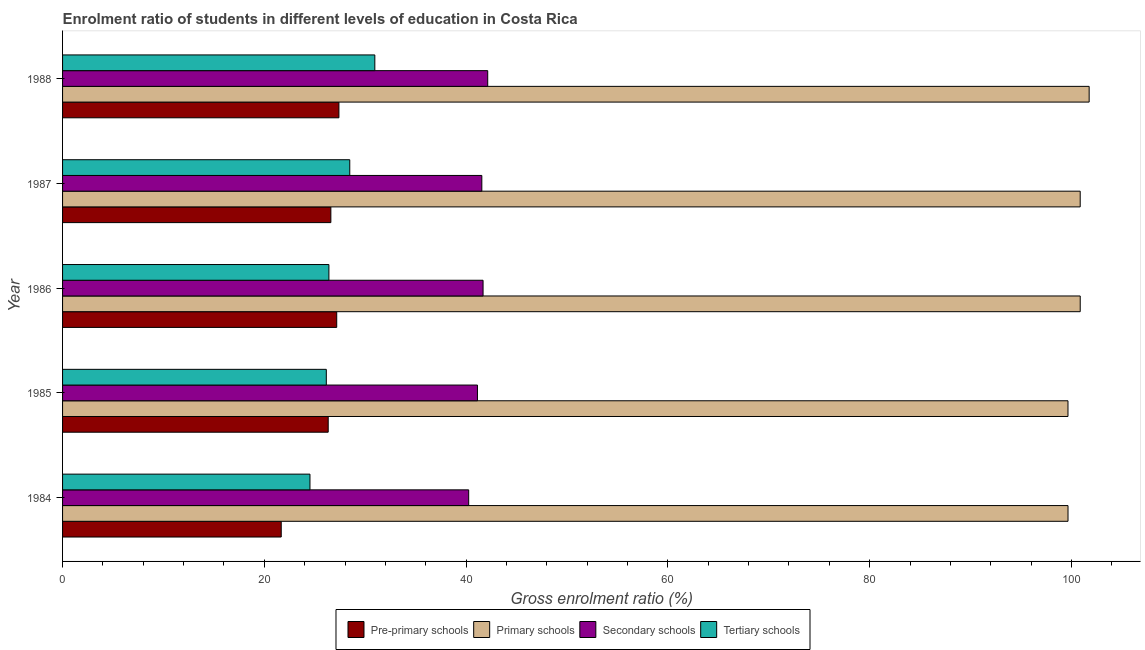How many groups of bars are there?
Provide a short and direct response. 5. Are the number of bars per tick equal to the number of legend labels?
Make the answer very short. Yes. What is the label of the 4th group of bars from the top?
Give a very brief answer. 1985. What is the gross enrolment ratio in primary schools in 1984?
Keep it short and to the point. 99.66. Across all years, what is the maximum gross enrolment ratio in tertiary schools?
Make the answer very short. 30.95. Across all years, what is the minimum gross enrolment ratio in tertiary schools?
Keep it short and to the point. 24.52. What is the total gross enrolment ratio in pre-primary schools in the graph?
Provide a short and direct response. 129.17. What is the difference between the gross enrolment ratio in tertiary schools in 1985 and that in 1986?
Provide a short and direct response. -0.26. What is the difference between the gross enrolment ratio in secondary schools in 1988 and the gross enrolment ratio in pre-primary schools in 1986?
Make the answer very short. 14.97. What is the average gross enrolment ratio in tertiary schools per year?
Your answer should be compact. 27.3. In the year 1985, what is the difference between the gross enrolment ratio in tertiary schools and gross enrolment ratio in primary schools?
Your response must be concise. -73.52. In how many years, is the gross enrolment ratio in primary schools greater than 48 %?
Give a very brief answer. 5. What is the ratio of the gross enrolment ratio in pre-primary schools in 1985 to that in 1988?
Keep it short and to the point. 0.96. What is the difference between the highest and the second highest gross enrolment ratio in pre-primary schools?
Make the answer very short. 0.22. What is the difference between the highest and the lowest gross enrolment ratio in tertiary schools?
Your answer should be very brief. 6.43. In how many years, is the gross enrolment ratio in primary schools greater than the average gross enrolment ratio in primary schools taken over all years?
Offer a very short reply. 3. Is the sum of the gross enrolment ratio in tertiary schools in 1985 and 1987 greater than the maximum gross enrolment ratio in primary schools across all years?
Ensure brevity in your answer.  No. What does the 1st bar from the top in 1987 represents?
Keep it short and to the point. Tertiary schools. What does the 4th bar from the bottom in 1988 represents?
Offer a terse response. Tertiary schools. Is it the case that in every year, the sum of the gross enrolment ratio in pre-primary schools and gross enrolment ratio in primary schools is greater than the gross enrolment ratio in secondary schools?
Give a very brief answer. Yes. Are all the bars in the graph horizontal?
Offer a terse response. Yes. Are the values on the major ticks of X-axis written in scientific E-notation?
Give a very brief answer. No. Does the graph contain any zero values?
Offer a terse response. No. Where does the legend appear in the graph?
Your response must be concise. Bottom center. How many legend labels are there?
Give a very brief answer. 4. How are the legend labels stacked?
Your answer should be very brief. Horizontal. What is the title of the graph?
Your response must be concise. Enrolment ratio of students in different levels of education in Costa Rica. What is the label or title of the X-axis?
Provide a short and direct response. Gross enrolment ratio (%). What is the Gross enrolment ratio (%) in Pre-primary schools in 1984?
Offer a terse response. 21.67. What is the Gross enrolment ratio (%) in Primary schools in 1984?
Ensure brevity in your answer.  99.66. What is the Gross enrolment ratio (%) in Secondary schools in 1984?
Provide a short and direct response. 40.26. What is the Gross enrolment ratio (%) of Tertiary schools in 1984?
Offer a very short reply. 24.52. What is the Gross enrolment ratio (%) in Pre-primary schools in 1985?
Ensure brevity in your answer.  26.33. What is the Gross enrolment ratio (%) of Primary schools in 1985?
Your response must be concise. 99.66. What is the Gross enrolment ratio (%) of Secondary schools in 1985?
Give a very brief answer. 41.13. What is the Gross enrolment ratio (%) of Tertiary schools in 1985?
Your answer should be very brief. 26.14. What is the Gross enrolment ratio (%) of Pre-primary schools in 1986?
Give a very brief answer. 27.17. What is the Gross enrolment ratio (%) of Primary schools in 1986?
Your answer should be compact. 100.87. What is the Gross enrolment ratio (%) of Secondary schools in 1986?
Ensure brevity in your answer.  41.68. What is the Gross enrolment ratio (%) in Tertiary schools in 1986?
Your answer should be very brief. 26.4. What is the Gross enrolment ratio (%) of Pre-primary schools in 1987?
Provide a succinct answer. 26.59. What is the Gross enrolment ratio (%) of Primary schools in 1987?
Give a very brief answer. 100.87. What is the Gross enrolment ratio (%) of Secondary schools in 1987?
Your response must be concise. 41.56. What is the Gross enrolment ratio (%) of Tertiary schools in 1987?
Offer a very short reply. 28.47. What is the Gross enrolment ratio (%) in Pre-primary schools in 1988?
Provide a short and direct response. 27.39. What is the Gross enrolment ratio (%) of Primary schools in 1988?
Ensure brevity in your answer.  101.76. What is the Gross enrolment ratio (%) in Secondary schools in 1988?
Offer a terse response. 42.14. What is the Gross enrolment ratio (%) in Tertiary schools in 1988?
Offer a terse response. 30.95. Across all years, what is the maximum Gross enrolment ratio (%) in Pre-primary schools?
Provide a short and direct response. 27.39. Across all years, what is the maximum Gross enrolment ratio (%) in Primary schools?
Give a very brief answer. 101.76. Across all years, what is the maximum Gross enrolment ratio (%) of Secondary schools?
Give a very brief answer. 42.14. Across all years, what is the maximum Gross enrolment ratio (%) in Tertiary schools?
Offer a terse response. 30.95. Across all years, what is the minimum Gross enrolment ratio (%) of Pre-primary schools?
Your answer should be compact. 21.67. Across all years, what is the minimum Gross enrolment ratio (%) in Primary schools?
Your answer should be compact. 99.66. Across all years, what is the minimum Gross enrolment ratio (%) in Secondary schools?
Your response must be concise. 40.26. Across all years, what is the minimum Gross enrolment ratio (%) in Tertiary schools?
Your response must be concise. 24.52. What is the total Gross enrolment ratio (%) in Pre-primary schools in the graph?
Provide a succinct answer. 129.17. What is the total Gross enrolment ratio (%) of Primary schools in the graph?
Your response must be concise. 502.82. What is the total Gross enrolment ratio (%) in Secondary schools in the graph?
Your answer should be very brief. 206.76. What is the total Gross enrolment ratio (%) of Tertiary schools in the graph?
Make the answer very short. 136.48. What is the difference between the Gross enrolment ratio (%) in Pre-primary schools in 1984 and that in 1985?
Your answer should be very brief. -4.66. What is the difference between the Gross enrolment ratio (%) of Primary schools in 1984 and that in 1985?
Keep it short and to the point. 0. What is the difference between the Gross enrolment ratio (%) of Secondary schools in 1984 and that in 1985?
Offer a terse response. -0.87. What is the difference between the Gross enrolment ratio (%) of Tertiary schools in 1984 and that in 1985?
Your answer should be very brief. -1.62. What is the difference between the Gross enrolment ratio (%) of Pre-primary schools in 1984 and that in 1986?
Provide a succinct answer. -5.5. What is the difference between the Gross enrolment ratio (%) of Primary schools in 1984 and that in 1986?
Offer a very short reply. -1.21. What is the difference between the Gross enrolment ratio (%) of Secondary schools in 1984 and that in 1986?
Your answer should be compact. -1.43. What is the difference between the Gross enrolment ratio (%) of Tertiary schools in 1984 and that in 1986?
Give a very brief answer. -1.88. What is the difference between the Gross enrolment ratio (%) in Pre-primary schools in 1984 and that in 1987?
Offer a terse response. -4.92. What is the difference between the Gross enrolment ratio (%) in Primary schools in 1984 and that in 1987?
Offer a terse response. -1.21. What is the difference between the Gross enrolment ratio (%) in Secondary schools in 1984 and that in 1987?
Your answer should be compact. -1.3. What is the difference between the Gross enrolment ratio (%) of Tertiary schools in 1984 and that in 1987?
Offer a terse response. -3.94. What is the difference between the Gross enrolment ratio (%) in Pre-primary schools in 1984 and that in 1988?
Provide a succinct answer. -5.72. What is the difference between the Gross enrolment ratio (%) in Primary schools in 1984 and that in 1988?
Give a very brief answer. -2.1. What is the difference between the Gross enrolment ratio (%) of Secondary schools in 1984 and that in 1988?
Your response must be concise. -1.89. What is the difference between the Gross enrolment ratio (%) in Tertiary schools in 1984 and that in 1988?
Offer a very short reply. -6.43. What is the difference between the Gross enrolment ratio (%) of Pre-primary schools in 1985 and that in 1986?
Your answer should be compact. -0.84. What is the difference between the Gross enrolment ratio (%) in Primary schools in 1985 and that in 1986?
Your answer should be compact. -1.21. What is the difference between the Gross enrolment ratio (%) in Secondary schools in 1985 and that in 1986?
Provide a short and direct response. -0.56. What is the difference between the Gross enrolment ratio (%) of Tertiary schools in 1985 and that in 1986?
Provide a short and direct response. -0.26. What is the difference between the Gross enrolment ratio (%) in Pre-primary schools in 1985 and that in 1987?
Keep it short and to the point. -0.26. What is the difference between the Gross enrolment ratio (%) of Primary schools in 1985 and that in 1987?
Make the answer very short. -1.21. What is the difference between the Gross enrolment ratio (%) of Secondary schools in 1985 and that in 1987?
Your response must be concise. -0.43. What is the difference between the Gross enrolment ratio (%) of Tertiary schools in 1985 and that in 1987?
Provide a short and direct response. -2.32. What is the difference between the Gross enrolment ratio (%) in Pre-primary schools in 1985 and that in 1988?
Keep it short and to the point. -1.06. What is the difference between the Gross enrolment ratio (%) of Primary schools in 1985 and that in 1988?
Give a very brief answer. -2.1. What is the difference between the Gross enrolment ratio (%) of Secondary schools in 1985 and that in 1988?
Give a very brief answer. -1.02. What is the difference between the Gross enrolment ratio (%) of Tertiary schools in 1985 and that in 1988?
Provide a succinct answer. -4.81. What is the difference between the Gross enrolment ratio (%) in Pre-primary schools in 1986 and that in 1987?
Make the answer very short. 0.58. What is the difference between the Gross enrolment ratio (%) of Primary schools in 1986 and that in 1987?
Provide a succinct answer. 0. What is the difference between the Gross enrolment ratio (%) of Secondary schools in 1986 and that in 1987?
Give a very brief answer. 0.12. What is the difference between the Gross enrolment ratio (%) of Tertiary schools in 1986 and that in 1987?
Your response must be concise. -2.07. What is the difference between the Gross enrolment ratio (%) in Pre-primary schools in 1986 and that in 1988?
Your answer should be compact. -0.22. What is the difference between the Gross enrolment ratio (%) in Primary schools in 1986 and that in 1988?
Give a very brief answer. -0.89. What is the difference between the Gross enrolment ratio (%) of Secondary schools in 1986 and that in 1988?
Offer a terse response. -0.46. What is the difference between the Gross enrolment ratio (%) of Tertiary schools in 1986 and that in 1988?
Your answer should be compact. -4.55. What is the difference between the Gross enrolment ratio (%) of Pre-primary schools in 1987 and that in 1988?
Your response must be concise. -0.8. What is the difference between the Gross enrolment ratio (%) in Primary schools in 1987 and that in 1988?
Provide a succinct answer. -0.89. What is the difference between the Gross enrolment ratio (%) in Secondary schools in 1987 and that in 1988?
Ensure brevity in your answer.  -0.58. What is the difference between the Gross enrolment ratio (%) in Tertiary schools in 1987 and that in 1988?
Your response must be concise. -2.48. What is the difference between the Gross enrolment ratio (%) in Pre-primary schools in 1984 and the Gross enrolment ratio (%) in Primary schools in 1985?
Your answer should be very brief. -77.98. What is the difference between the Gross enrolment ratio (%) in Pre-primary schools in 1984 and the Gross enrolment ratio (%) in Secondary schools in 1985?
Provide a short and direct response. -19.45. What is the difference between the Gross enrolment ratio (%) in Pre-primary schools in 1984 and the Gross enrolment ratio (%) in Tertiary schools in 1985?
Keep it short and to the point. -4.47. What is the difference between the Gross enrolment ratio (%) in Primary schools in 1984 and the Gross enrolment ratio (%) in Secondary schools in 1985?
Make the answer very short. 58.54. What is the difference between the Gross enrolment ratio (%) in Primary schools in 1984 and the Gross enrolment ratio (%) in Tertiary schools in 1985?
Ensure brevity in your answer.  73.52. What is the difference between the Gross enrolment ratio (%) of Secondary schools in 1984 and the Gross enrolment ratio (%) of Tertiary schools in 1985?
Offer a very short reply. 14.11. What is the difference between the Gross enrolment ratio (%) of Pre-primary schools in 1984 and the Gross enrolment ratio (%) of Primary schools in 1986?
Your response must be concise. -79.2. What is the difference between the Gross enrolment ratio (%) in Pre-primary schools in 1984 and the Gross enrolment ratio (%) in Secondary schools in 1986?
Make the answer very short. -20.01. What is the difference between the Gross enrolment ratio (%) of Pre-primary schools in 1984 and the Gross enrolment ratio (%) of Tertiary schools in 1986?
Provide a short and direct response. -4.72. What is the difference between the Gross enrolment ratio (%) in Primary schools in 1984 and the Gross enrolment ratio (%) in Secondary schools in 1986?
Your answer should be very brief. 57.98. What is the difference between the Gross enrolment ratio (%) in Primary schools in 1984 and the Gross enrolment ratio (%) in Tertiary schools in 1986?
Make the answer very short. 73.26. What is the difference between the Gross enrolment ratio (%) in Secondary schools in 1984 and the Gross enrolment ratio (%) in Tertiary schools in 1986?
Your answer should be very brief. 13.86. What is the difference between the Gross enrolment ratio (%) in Pre-primary schools in 1984 and the Gross enrolment ratio (%) in Primary schools in 1987?
Your answer should be compact. -79.2. What is the difference between the Gross enrolment ratio (%) in Pre-primary schools in 1984 and the Gross enrolment ratio (%) in Secondary schools in 1987?
Give a very brief answer. -19.88. What is the difference between the Gross enrolment ratio (%) in Pre-primary schools in 1984 and the Gross enrolment ratio (%) in Tertiary schools in 1987?
Provide a short and direct response. -6.79. What is the difference between the Gross enrolment ratio (%) in Primary schools in 1984 and the Gross enrolment ratio (%) in Secondary schools in 1987?
Provide a succinct answer. 58.1. What is the difference between the Gross enrolment ratio (%) of Primary schools in 1984 and the Gross enrolment ratio (%) of Tertiary schools in 1987?
Your answer should be very brief. 71.19. What is the difference between the Gross enrolment ratio (%) of Secondary schools in 1984 and the Gross enrolment ratio (%) of Tertiary schools in 1987?
Keep it short and to the point. 11.79. What is the difference between the Gross enrolment ratio (%) of Pre-primary schools in 1984 and the Gross enrolment ratio (%) of Primary schools in 1988?
Offer a very short reply. -80.08. What is the difference between the Gross enrolment ratio (%) of Pre-primary schools in 1984 and the Gross enrolment ratio (%) of Secondary schools in 1988?
Give a very brief answer. -20.47. What is the difference between the Gross enrolment ratio (%) in Pre-primary schools in 1984 and the Gross enrolment ratio (%) in Tertiary schools in 1988?
Your response must be concise. -9.28. What is the difference between the Gross enrolment ratio (%) of Primary schools in 1984 and the Gross enrolment ratio (%) of Secondary schools in 1988?
Provide a short and direct response. 57.52. What is the difference between the Gross enrolment ratio (%) of Primary schools in 1984 and the Gross enrolment ratio (%) of Tertiary schools in 1988?
Provide a short and direct response. 68.71. What is the difference between the Gross enrolment ratio (%) in Secondary schools in 1984 and the Gross enrolment ratio (%) in Tertiary schools in 1988?
Your answer should be compact. 9.3. What is the difference between the Gross enrolment ratio (%) of Pre-primary schools in 1985 and the Gross enrolment ratio (%) of Primary schools in 1986?
Your answer should be very brief. -74.54. What is the difference between the Gross enrolment ratio (%) in Pre-primary schools in 1985 and the Gross enrolment ratio (%) in Secondary schools in 1986?
Make the answer very short. -15.35. What is the difference between the Gross enrolment ratio (%) in Pre-primary schools in 1985 and the Gross enrolment ratio (%) in Tertiary schools in 1986?
Offer a very short reply. -0.07. What is the difference between the Gross enrolment ratio (%) in Primary schools in 1985 and the Gross enrolment ratio (%) in Secondary schools in 1986?
Provide a short and direct response. 57.98. What is the difference between the Gross enrolment ratio (%) in Primary schools in 1985 and the Gross enrolment ratio (%) in Tertiary schools in 1986?
Offer a very short reply. 73.26. What is the difference between the Gross enrolment ratio (%) in Secondary schools in 1985 and the Gross enrolment ratio (%) in Tertiary schools in 1986?
Provide a short and direct response. 14.73. What is the difference between the Gross enrolment ratio (%) in Pre-primary schools in 1985 and the Gross enrolment ratio (%) in Primary schools in 1987?
Offer a very short reply. -74.54. What is the difference between the Gross enrolment ratio (%) in Pre-primary schools in 1985 and the Gross enrolment ratio (%) in Secondary schools in 1987?
Provide a short and direct response. -15.23. What is the difference between the Gross enrolment ratio (%) of Pre-primary schools in 1985 and the Gross enrolment ratio (%) of Tertiary schools in 1987?
Your answer should be compact. -2.14. What is the difference between the Gross enrolment ratio (%) of Primary schools in 1985 and the Gross enrolment ratio (%) of Secondary schools in 1987?
Ensure brevity in your answer.  58.1. What is the difference between the Gross enrolment ratio (%) of Primary schools in 1985 and the Gross enrolment ratio (%) of Tertiary schools in 1987?
Give a very brief answer. 71.19. What is the difference between the Gross enrolment ratio (%) of Secondary schools in 1985 and the Gross enrolment ratio (%) of Tertiary schools in 1987?
Give a very brief answer. 12.66. What is the difference between the Gross enrolment ratio (%) of Pre-primary schools in 1985 and the Gross enrolment ratio (%) of Primary schools in 1988?
Ensure brevity in your answer.  -75.43. What is the difference between the Gross enrolment ratio (%) of Pre-primary schools in 1985 and the Gross enrolment ratio (%) of Secondary schools in 1988?
Offer a terse response. -15.81. What is the difference between the Gross enrolment ratio (%) of Pre-primary schools in 1985 and the Gross enrolment ratio (%) of Tertiary schools in 1988?
Ensure brevity in your answer.  -4.62. What is the difference between the Gross enrolment ratio (%) in Primary schools in 1985 and the Gross enrolment ratio (%) in Secondary schools in 1988?
Provide a succinct answer. 57.52. What is the difference between the Gross enrolment ratio (%) of Primary schools in 1985 and the Gross enrolment ratio (%) of Tertiary schools in 1988?
Keep it short and to the point. 68.71. What is the difference between the Gross enrolment ratio (%) in Secondary schools in 1985 and the Gross enrolment ratio (%) in Tertiary schools in 1988?
Give a very brief answer. 10.17. What is the difference between the Gross enrolment ratio (%) in Pre-primary schools in 1986 and the Gross enrolment ratio (%) in Primary schools in 1987?
Provide a succinct answer. -73.7. What is the difference between the Gross enrolment ratio (%) in Pre-primary schools in 1986 and the Gross enrolment ratio (%) in Secondary schools in 1987?
Make the answer very short. -14.38. What is the difference between the Gross enrolment ratio (%) of Pre-primary schools in 1986 and the Gross enrolment ratio (%) of Tertiary schools in 1987?
Offer a terse response. -1.29. What is the difference between the Gross enrolment ratio (%) in Primary schools in 1986 and the Gross enrolment ratio (%) in Secondary schools in 1987?
Make the answer very short. 59.31. What is the difference between the Gross enrolment ratio (%) in Primary schools in 1986 and the Gross enrolment ratio (%) in Tertiary schools in 1987?
Provide a short and direct response. 72.4. What is the difference between the Gross enrolment ratio (%) in Secondary schools in 1986 and the Gross enrolment ratio (%) in Tertiary schools in 1987?
Offer a very short reply. 13.21. What is the difference between the Gross enrolment ratio (%) of Pre-primary schools in 1986 and the Gross enrolment ratio (%) of Primary schools in 1988?
Ensure brevity in your answer.  -74.58. What is the difference between the Gross enrolment ratio (%) of Pre-primary schools in 1986 and the Gross enrolment ratio (%) of Secondary schools in 1988?
Make the answer very short. -14.97. What is the difference between the Gross enrolment ratio (%) of Pre-primary schools in 1986 and the Gross enrolment ratio (%) of Tertiary schools in 1988?
Ensure brevity in your answer.  -3.78. What is the difference between the Gross enrolment ratio (%) in Primary schools in 1986 and the Gross enrolment ratio (%) in Secondary schools in 1988?
Ensure brevity in your answer.  58.73. What is the difference between the Gross enrolment ratio (%) of Primary schools in 1986 and the Gross enrolment ratio (%) of Tertiary schools in 1988?
Offer a very short reply. 69.92. What is the difference between the Gross enrolment ratio (%) of Secondary schools in 1986 and the Gross enrolment ratio (%) of Tertiary schools in 1988?
Keep it short and to the point. 10.73. What is the difference between the Gross enrolment ratio (%) in Pre-primary schools in 1987 and the Gross enrolment ratio (%) in Primary schools in 1988?
Give a very brief answer. -75.17. What is the difference between the Gross enrolment ratio (%) of Pre-primary schools in 1987 and the Gross enrolment ratio (%) of Secondary schools in 1988?
Provide a succinct answer. -15.55. What is the difference between the Gross enrolment ratio (%) in Pre-primary schools in 1987 and the Gross enrolment ratio (%) in Tertiary schools in 1988?
Your answer should be very brief. -4.36. What is the difference between the Gross enrolment ratio (%) in Primary schools in 1987 and the Gross enrolment ratio (%) in Secondary schools in 1988?
Give a very brief answer. 58.73. What is the difference between the Gross enrolment ratio (%) in Primary schools in 1987 and the Gross enrolment ratio (%) in Tertiary schools in 1988?
Offer a very short reply. 69.92. What is the difference between the Gross enrolment ratio (%) of Secondary schools in 1987 and the Gross enrolment ratio (%) of Tertiary schools in 1988?
Your response must be concise. 10.61. What is the average Gross enrolment ratio (%) of Pre-primary schools per year?
Offer a very short reply. 25.83. What is the average Gross enrolment ratio (%) in Primary schools per year?
Keep it short and to the point. 100.56. What is the average Gross enrolment ratio (%) in Secondary schools per year?
Keep it short and to the point. 41.35. What is the average Gross enrolment ratio (%) of Tertiary schools per year?
Your response must be concise. 27.3. In the year 1984, what is the difference between the Gross enrolment ratio (%) of Pre-primary schools and Gross enrolment ratio (%) of Primary schools?
Offer a very short reply. -77.99. In the year 1984, what is the difference between the Gross enrolment ratio (%) of Pre-primary schools and Gross enrolment ratio (%) of Secondary schools?
Your answer should be very brief. -18.58. In the year 1984, what is the difference between the Gross enrolment ratio (%) of Pre-primary schools and Gross enrolment ratio (%) of Tertiary schools?
Provide a succinct answer. -2.85. In the year 1984, what is the difference between the Gross enrolment ratio (%) of Primary schools and Gross enrolment ratio (%) of Secondary schools?
Your answer should be compact. 59.41. In the year 1984, what is the difference between the Gross enrolment ratio (%) of Primary schools and Gross enrolment ratio (%) of Tertiary schools?
Your answer should be compact. 75.14. In the year 1984, what is the difference between the Gross enrolment ratio (%) in Secondary schools and Gross enrolment ratio (%) in Tertiary schools?
Provide a succinct answer. 15.73. In the year 1985, what is the difference between the Gross enrolment ratio (%) in Pre-primary schools and Gross enrolment ratio (%) in Primary schools?
Offer a terse response. -73.33. In the year 1985, what is the difference between the Gross enrolment ratio (%) in Pre-primary schools and Gross enrolment ratio (%) in Secondary schools?
Ensure brevity in your answer.  -14.79. In the year 1985, what is the difference between the Gross enrolment ratio (%) in Pre-primary schools and Gross enrolment ratio (%) in Tertiary schools?
Your answer should be very brief. 0.19. In the year 1985, what is the difference between the Gross enrolment ratio (%) in Primary schools and Gross enrolment ratio (%) in Secondary schools?
Your answer should be very brief. 58.53. In the year 1985, what is the difference between the Gross enrolment ratio (%) of Primary schools and Gross enrolment ratio (%) of Tertiary schools?
Ensure brevity in your answer.  73.52. In the year 1985, what is the difference between the Gross enrolment ratio (%) of Secondary schools and Gross enrolment ratio (%) of Tertiary schools?
Your response must be concise. 14.98. In the year 1986, what is the difference between the Gross enrolment ratio (%) in Pre-primary schools and Gross enrolment ratio (%) in Primary schools?
Give a very brief answer. -73.7. In the year 1986, what is the difference between the Gross enrolment ratio (%) in Pre-primary schools and Gross enrolment ratio (%) in Secondary schools?
Keep it short and to the point. -14.51. In the year 1986, what is the difference between the Gross enrolment ratio (%) of Pre-primary schools and Gross enrolment ratio (%) of Tertiary schools?
Your answer should be very brief. 0.78. In the year 1986, what is the difference between the Gross enrolment ratio (%) in Primary schools and Gross enrolment ratio (%) in Secondary schools?
Offer a terse response. 59.19. In the year 1986, what is the difference between the Gross enrolment ratio (%) of Primary schools and Gross enrolment ratio (%) of Tertiary schools?
Your answer should be very brief. 74.47. In the year 1986, what is the difference between the Gross enrolment ratio (%) of Secondary schools and Gross enrolment ratio (%) of Tertiary schools?
Offer a terse response. 15.28. In the year 1987, what is the difference between the Gross enrolment ratio (%) of Pre-primary schools and Gross enrolment ratio (%) of Primary schools?
Your answer should be very brief. -74.28. In the year 1987, what is the difference between the Gross enrolment ratio (%) in Pre-primary schools and Gross enrolment ratio (%) in Secondary schools?
Offer a very short reply. -14.97. In the year 1987, what is the difference between the Gross enrolment ratio (%) in Pre-primary schools and Gross enrolment ratio (%) in Tertiary schools?
Provide a succinct answer. -1.87. In the year 1987, what is the difference between the Gross enrolment ratio (%) of Primary schools and Gross enrolment ratio (%) of Secondary schools?
Give a very brief answer. 59.31. In the year 1987, what is the difference between the Gross enrolment ratio (%) of Primary schools and Gross enrolment ratio (%) of Tertiary schools?
Make the answer very short. 72.4. In the year 1987, what is the difference between the Gross enrolment ratio (%) of Secondary schools and Gross enrolment ratio (%) of Tertiary schools?
Make the answer very short. 13.09. In the year 1988, what is the difference between the Gross enrolment ratio (%) of Pre-primary schools and Gross enrolment ratio (%) of Primary schools?
Give a very brief answer. -74.37. In the year 1988, what is the difference between the Gross enrolment ratio (%) of Pre-primary schools and Gross enrolment ratio (%) of Secondary schools?
Provide a succinct answer. -14.75. In the year 1988, what is the difference between the Gross enrolment ratio (%) of Pre-primary schools and Gross enrolment ratio (%) of Tertiary schools?
Offer a terse response. -3.56. In the year 1988, what is the difference between the Gross enrolment ratio (%) in Primary schools and Gross enrolment ratio (%) in Secondary schools?
Provide a short and direct response. 59.62. In the year 1988, what is the difference between the Gross enrolment ratio (%) of Primary schools and Gross enrolment ratio (%) of Tertiary schools?
Offer a terse response. 70.81. In the year 1988, what is the difference between the Gross enrolment ratio (%) of Secondary schools and Gross enrolment ratio (%) of Tertiary schools?
Give a very brief answer. 11.19. What is the ratio of the Gross enrolment ratio (%) of Pre-primary schools in 1984 to that in 1985?
Your response must be concise. 0.82. What is the ratio of the Gross enrolment ratio (%) in Primary schools in 1984 to that in 1985?
Your answer should be compact. 1. What is the ratio of the Gross enrolment ratio (%) of Secondary schools in 1984 to that in 1985?
Make the answer very short. 0.98. What is the ratio of the Gross enrolment ratio (%) in Tertiary schools in 1984 to that in 1985?
Offer a very short reply. 0.94. What is the ratio of the Gross enrolment ratio (%) of Pre-primary schools in 1984 to that in 1986?
Keep it short and to the point. 0.8. What is the ratio of the Gross enrolment ratio (%) of Primary schools in 1984 to that in 1986?
Provide a succinct answer. 0.99. What is the ratio of the Gross enrolment ratio (%) in Secondary schools in 1984 to that in 1986?
Your answer should be very brief. 0.97. What is the ratio of the Gross enrolment ratio (%) of Tertiary schools in 1984 to that in 1986?
Offer a terse response. 0.93. What is the ratio of the Gross enrolment ratio (%) in Pre-primary schools in 1984 to that in 1987?
Provide a short and direct response. 0.82. What is the ratio of the Gross enrolment ratio (%) of Secondary schools in 1984 to that in 1987?
Make the answer very short. 0.97. What is the ratio of the Gross enrolment ratio (%) in Tertiary schools in 1984 to that in 1987?
Ensure brevity in your answer.  0.86. What is the ratio of the Gross enrolment ratio (%) in Pre-primary schools in 1984 to that in 1988?
Provide a succinct answer. 0.79. What is the ratio of the Gross enrolment ratio (%) in Primary schools in 1984 to that in 1988?
Keep it short and to the point. 0.98. What is the ratio of the Gross enrolment ratio (%) in Secondary schools in 1984 to that in 1988?
Provide a short and direct response. 0.96. What is the ratio of the Gross enrolment ratio (%) in Tertiary schools in 1984 to that in 1988?
Your answer should be very brief. 0.79. What is the ratio of the Gross enrolment ratio (%) of Pre-primary schools in 1985 to that in 1986?
Keep it short and to the point. 0.97. What is the ratio of the Gross enrolment ratio (%) of Primary schools in 1985 to that in 1986?
Your response must be concise. 0.99. What is the ratio of the Gross enrolment ratio (%) of Secondary schools in 1985 to that in 1986?
Ensure brevity in your answer.  0.99. What is the ratio of the Gross enrolment ratio (%) of Tertiary schools in 1985 to that in 1986?
Make the answer very short. 0.99. What is the ratio of the Gross enrolment ratio (%) in Secondary schools in 1985 to that in 1987?
Offer a very short reply. 0.99. What is the ratio of the Gross enrolment ratio (%) of Tertiary schools in 1985 to that in 1987?
Offer a very short reply. 0.92. What is the ratio of the Gross enrolment ratio (%) in Pre-primary schools in 1985 to that in 1988?
Make the answer very short. 0.96. What is the ratio of the Gross enrolment ratio (%) in Primary schools in 1985 to that in 1988?
Offer a very short reply. 0.98. What is the ratio of the Gross enrolment ratio (%) in Secondary schools in 1985 to that in 1988?
Provide a short and direct response. 0.98. What is the ratio of the Gross enrolment ratio (%) in Tertiary schools in 1985 to that in 1988?
Offer a very short reply. 0.84. What is the ratio of the Gross enrolment ratio (%) in Pre-primary schools in 1986 to that in 1987?
Give a very brief answer. 1.02. What is the ratio of the Gross enrolment ratio (%) of Primary schools in 1986 to that in 1987?
Keep it short and to the point. 1. What is the ratio of the Gross enrolment ratio (%) of Tertiary schools in 1986 to that in 1987?
Offer a very short reply. 0.93. What is the ratio of the Gross enrolment ratio (%) in Pre-primary schools in 1986 to that in 1988?
Offer a very short reply. 0.99. What is the ratio of the Gross enrolment ratio (%) of Tertiary schools in 1986 to that in 1988?
Ensure brevity in your answer.  0.85. What is the ratio of the Gross enrolment ratio (%) of Pre-primary schools in 1987 to that in 1988?
Keep it short and to the point. 0.97. What is the ratio of the Gross enrolment ratio (%) of Secondary schools in 1987 to that in 1988?
Your response must be concise. 0.99. What is the ratio of the Gross enrolment ratio (%) in Tertiary schools in 1987 to that in 1988?
Offer a very short reply. 0.92. What is the difference between the highest and the second highest Gross enrolment ratio (%) of Pre-primary schools?
Give a very brief answer. 0.22. What is the difference between the highest and the second highest Gross enrolment ratio (%) of Primary schools?
Your answer should be very brief. 0.89. What is the difference between the highest and the second highest Gross enrolment ratio (%) of Secondary schools?
Keep it short and to the point. 0.46. What is the difference between the highest and the second highest Gross enrolment ratio (%) in Tertiary schools?
Provide a short and direct response. 2.48. What is the difference between the highest and the lowest Gross enrolment ratio (%) of Pre-primary schools?
Your response must be concise. 5.72. What is the difference between the highest and the lowest Gross enrolment ratio (%) in Primary schools?
Offer a very short reply. 2.1. What is the difference between the highest and the lowest Gross enrolment ratio (%) of Secondary schools?
Keep it short and to the point. 1.89. What is the difference between the highest and the lowest Gross enrolment ratio (%) of Tertiary schools?
Provide a short and direct response. 6.43. 